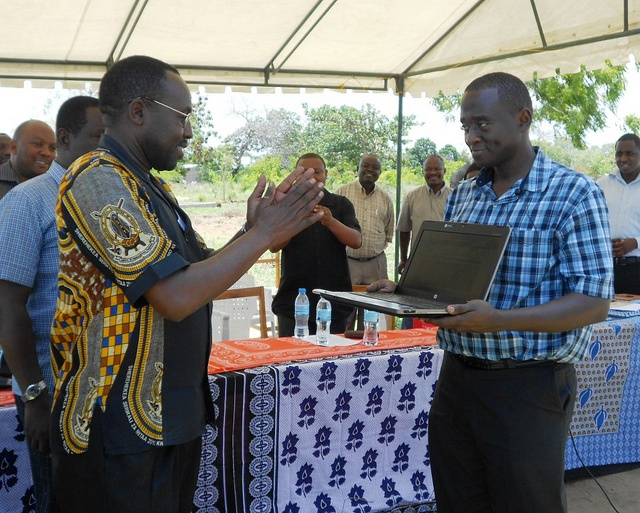Describe the objects in this image and their specific colors. I can see people in beige, black, gray, olive, and maroon tones, people in beige, black, gray, navy, and blue tones, people in beige, black, gray, and navy tones, laptop in beige, black, gray, and darkgray tones, and people in beige, black, maroon, and gray tones in this image. 